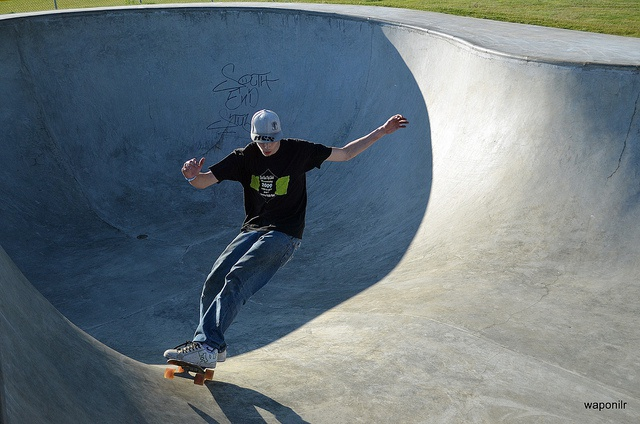Describe the objects in this image and their specific colors. I can see people in olive, black, gray, navy, and blue tones and skateboard in olive, black, maroon, brown, and gray tones in this image. 